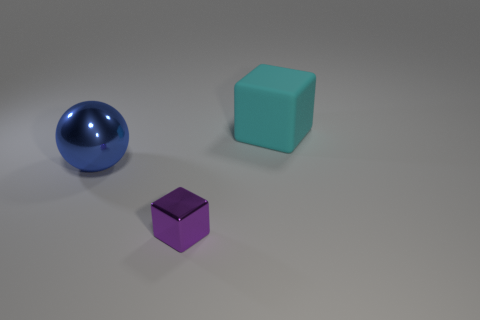Subtract all purple spheres. Subtract all green cylinders. How many spheres are left? 1 Subtract all purple cubes. How many green balls are left? 0 Subtract all tiny brown cylinders. Subtract all large blue things. How many objects are left? 2 Add 1 big metallic balls. How many big metallic balls are left? 2 Add 1 big green cylinders. How many big green cylinders exist? 1 Add 2 big metal objects. How many objects exist? 5 Subtract 0 cyan balls. How many objects are left? 3 Subtract all spheres. How many objects are left? 2 Subtract 1 cubes. How many cubes are left? 1 